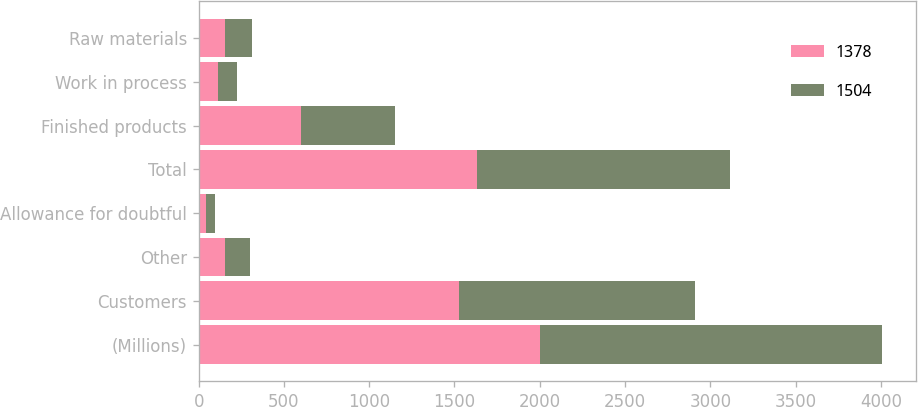Convert chart. <chart><loc_0><loc_0><loc_500><loc_500><stacked_bar_chart><ecel><fcel>(Millions)<fcel>Customers<fcel>Other<fcel>Allowance for doubtful<fcel>Total<fcel>Finished products<fcel>Work in process<fcel>Raw materials<nl><fcel>1378<fcel>2003<fcel>1524<fcel>152<fcel>45<fcel>1631<fcel>601<fcel>111<fcel>157<nl><fcel>1504<fcel>2002<fcel>1387<fcel>147<fcel>48<fcel>1486<fcel>548<fcel>113<fcel>157<nl></chart> 